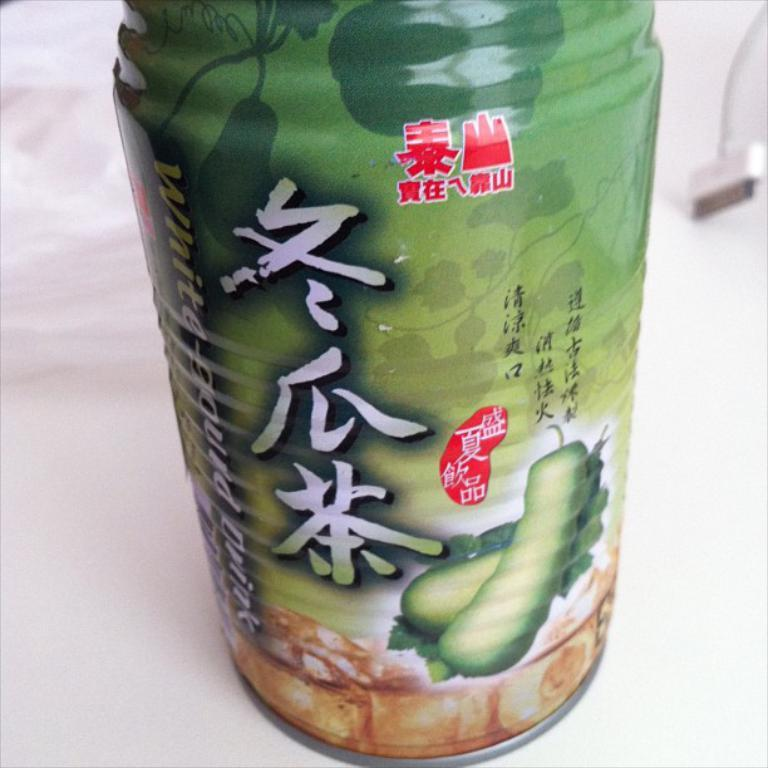What is the main subject of the image? There is an object on a white platform in the image. What is the color of the platform? The platform is white. What can be seen in the background of the image? The background of the image is white. How does the object in the image show respect to the basket? There is no basket present in the image, so it cannot be determined if the object is showing respect to it. 